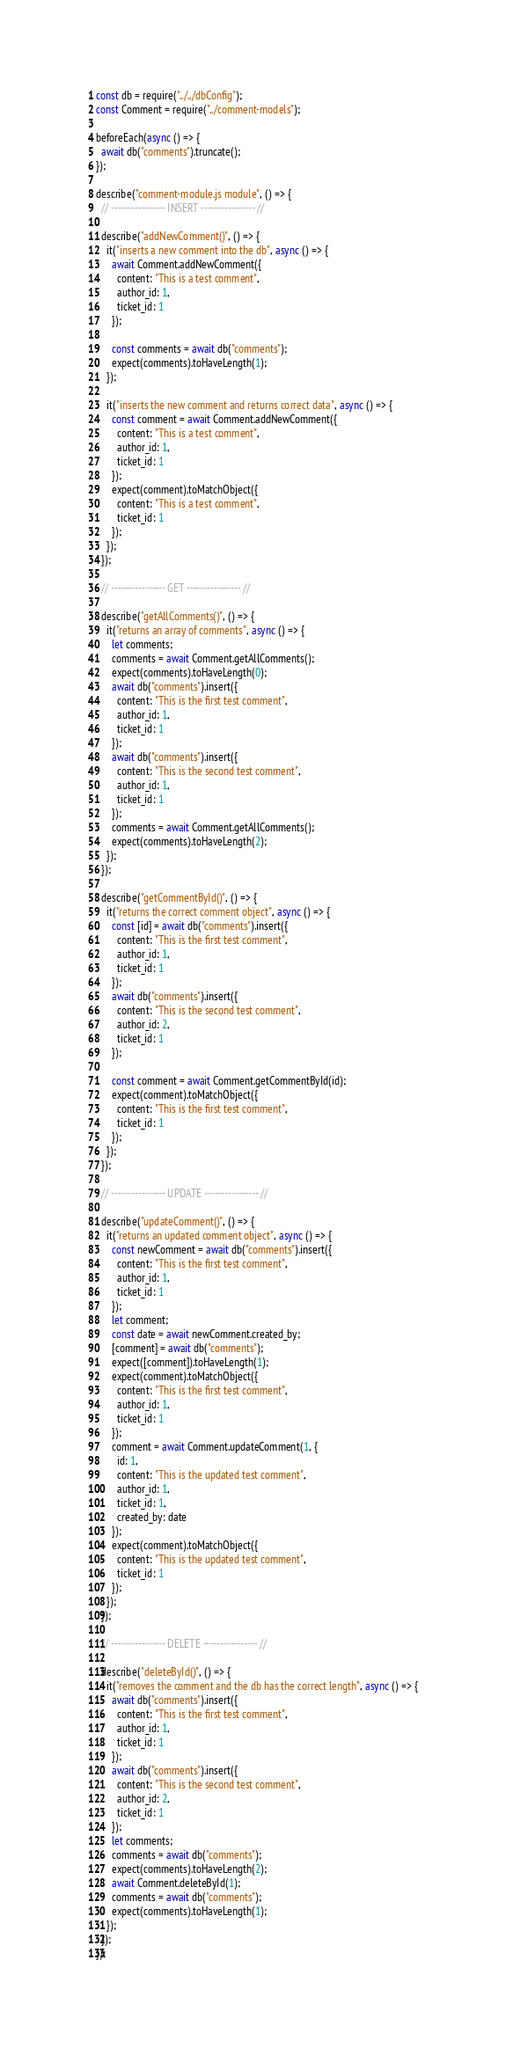<code> <loc_0><loc_0><loc_500><loc_500><_JavaScript_>const db = require("../../dbConfig");
const Comment = require("../comment-models");

beforeEach(async () => {
  await db("comments").truncate();
});

describe("comment-module.js module", () => {
  // ---------------- INSERT ---------------- //

  describe("addNewComment()", () => {
    it("inserts a new comment into the db", async () => {
      await Comment.addNewComment({
        content: "This is a test comment",
        author_id: 1,
        ticket_id: 1
      });

      const comments = await db("comments");
      expect(comments).toHaveLength(1);
    });

    it("inserts the new comment and returns correct data", async () => {
      const comment = await Comment.addNewComment({
        content: "This is a test comment",
        author_id: 1,
        ticket_id: 1
      });
      expect(comment).toMatchObject({
        content: "This is a test comment",
        ticket_id: 1
      });
    });
  });

  // ---------------- GET ---------------- //

  describe("getAllComments()", () => {
    it("returns an array of comments", async () => {
      let comments;
      comments = await Comment.getAllComments();
      expect(comments).toHaveLength(0);
      await db("comments").insert({
        content: "This is the first test comment",
        author_id: 1,
        ticket_id: 1
      });
      await db("comments").insert({
        content: "This is the second test comment",
        author_id: 1,
        ticket_id: 1
      });
      comments = await Comment.getAllComments();
      expect(comments).toHaveLength(2);
    });
  });

  describe("getCommentById()", () => {
    it("returns the correct comment object", async () => {
      const [id] = await db("comments").insert({
        content: "This is the first test comment",
        author_id: 1,
        ticket_id: 1
      });
      await db("comments").insert({
        content: "This is the second test comment",
        author_id: 2,
        ticket_id: 1
      });

      const comment = await Comment.getCommentById(id);
      expect(comment).toMatchObject({
        content: "This is the first test comment",
        ticket_id: 1
      });
    });
  });

  // ---------------- UPDATE ---------------- //

  describe("updateComment()", () => {
    it("returns an updated comment object", async () => {
      const newComment = await db("comments").insert({
        content: "This is the first test comment",
        author_id: 1,
        ticket_id: 1
      });
      let comment;
      const date = await newComment.created_by;
      [comment] = await db("comments");
      expect([comment]).toHaveLength(1);
      expect(comment).toMatchObject({
        content: "This is the first test comment",
        author_id: 1,
        ticket_id: 1
      });
      comment = await Comment.updateComment(1, {
        id: 1,
        content: "This is the updated test comment",
        author_id: 1,
        ticket_id: 1,
        created_by: date
      });
      expect(comment).toMatchObject({
        content: "This is the updated test comment",
        ticket_id: 1
      });
    });
  });

  // ---------------- DELETE ---------------- //

  describe("deleteById()", () => {
    it("removes the comment and the db has the correct length", async () => {
      await db("comments").insert({
        content: "This is the first test comment",
        author_id: 1,
        ticket_id: 1
      });
      await db("comments").insert({
        content: "This is the second test comment",
        author_id: 2,
        ticket_id: 1
      });
      let comments;
      comments = await db("comments");
      expect(comments).toHaveLength(2);
      await Comment.deleteById(1);
      comments = await db("comments");
      expect(comments).toHaveLength(1);
    });
  });
});
</code> 